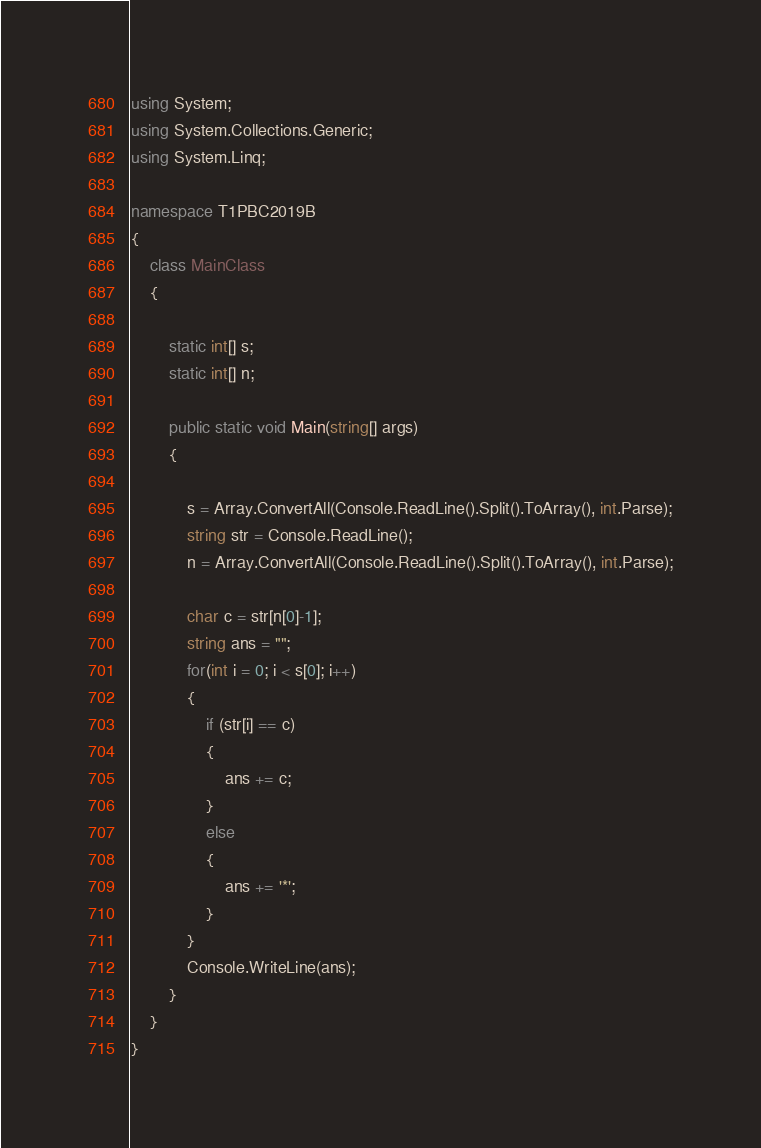Convert code to text. <code><loc_0><loc_0><loc_500><loc_500><_C#_>using System;
using System.Collections.Generic;
using System.Linq;

namespace T1PBC2019B
{
    class MainClass
    {

        static int[] s;
        static int[] n;

        public static void Main(string[] args)
        {
            
            s = Array.ConvertAll(Console.ReadLine().Split().ToArray(), int.Parse);
            string str = Console.ReadLine();
            n = Array.ConvertAll(Console.ReadLine().Split().ToArray(), int.Parse);

            char c = str[n[0]-1];
            string ans = "";
            for(int i = 0; i < s[0]; i++)
            {
                if (str[i] == c)
                {
                    ans += c;
                }
                else
                {
                    ans += '*';
                }
            }
            Console.WriteLine(ans);
        }
    }
}
</code> 